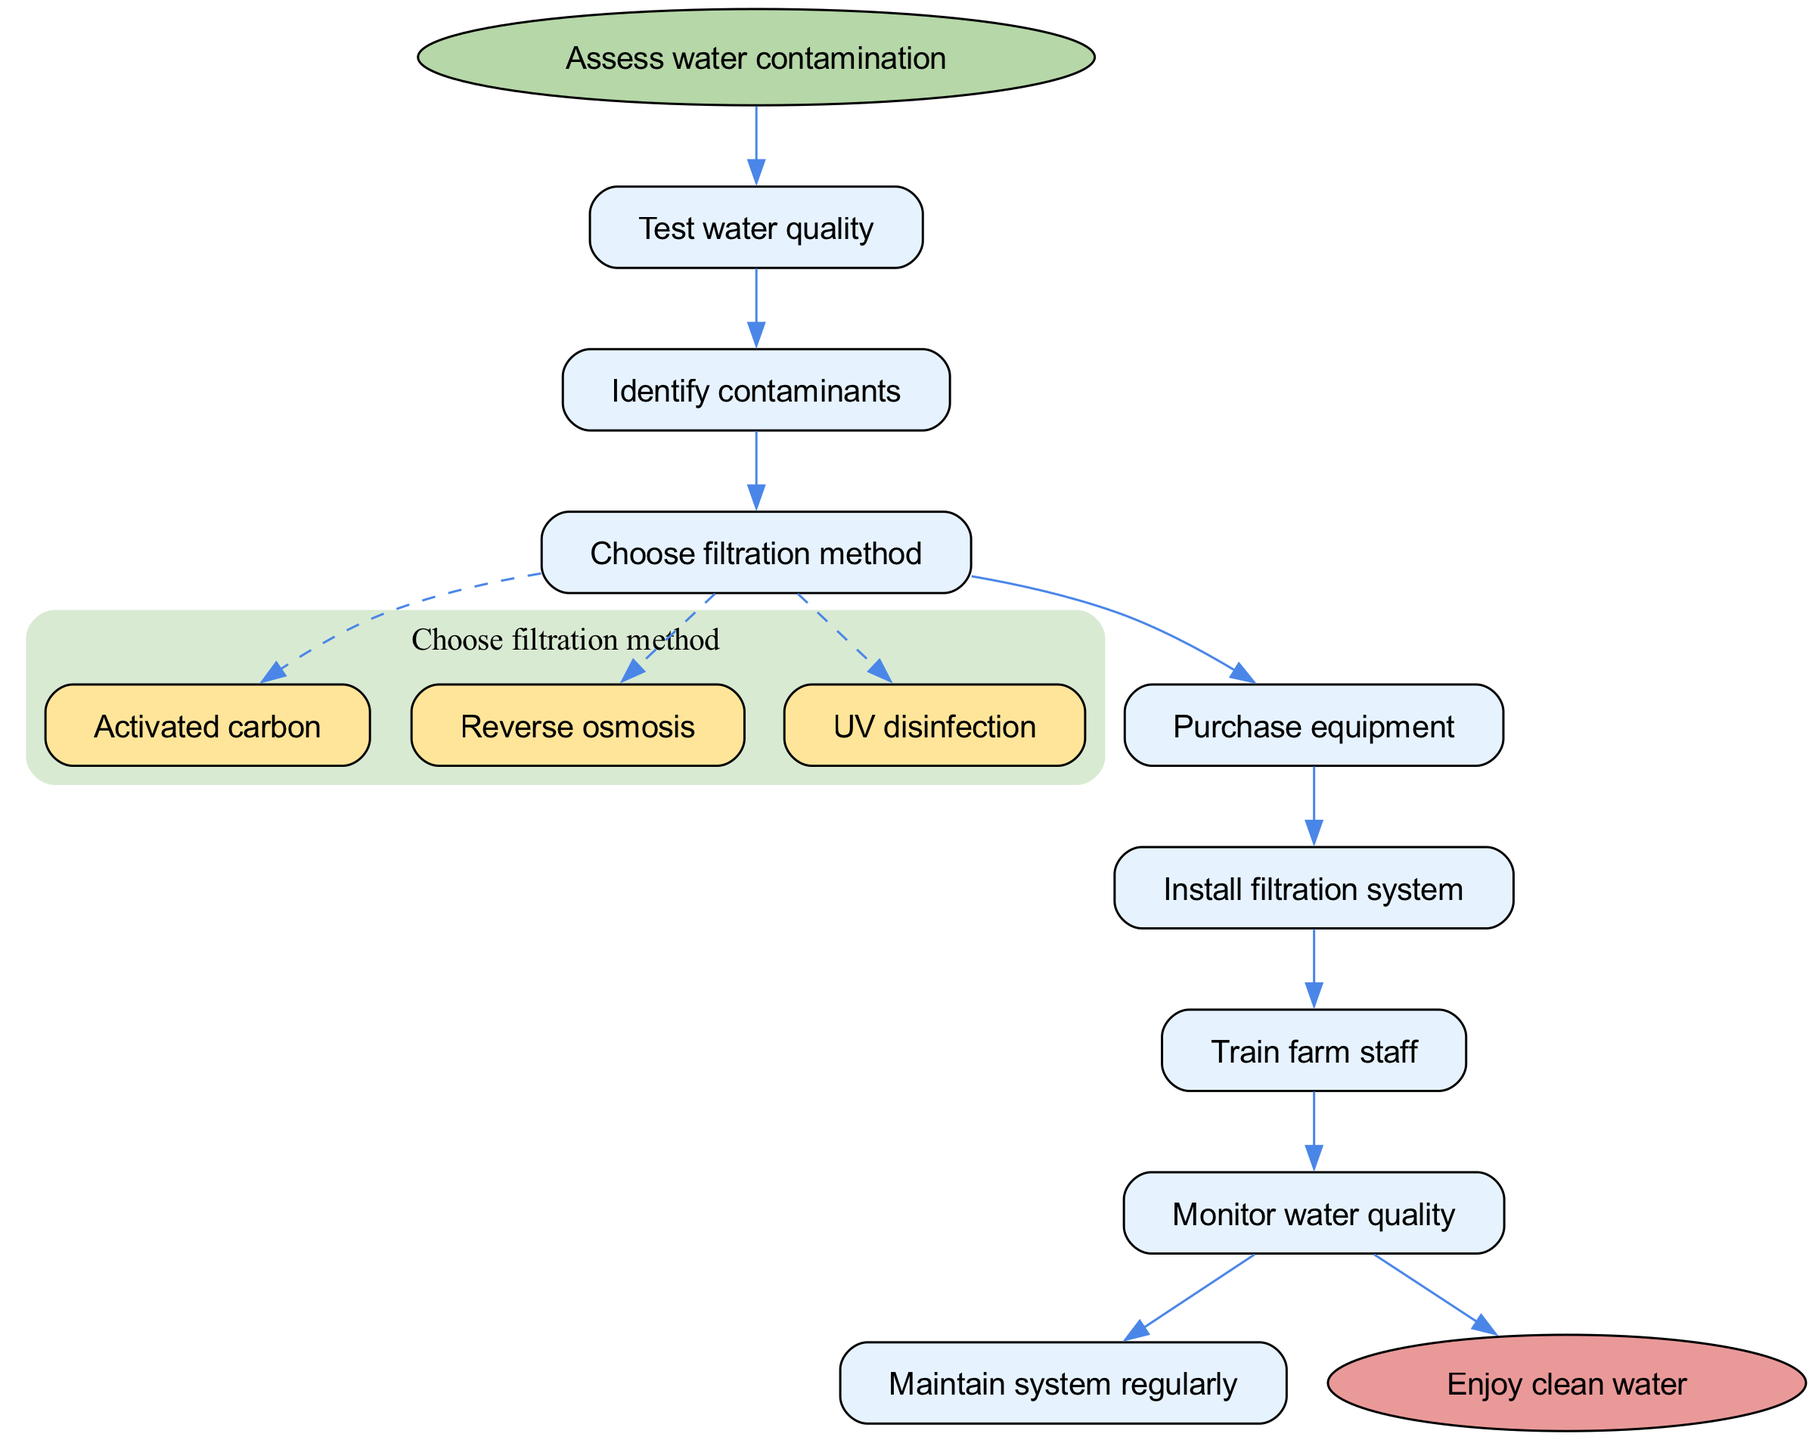What is the first step in the diagram? The first step in the diagram is labeled as "Assess water contamination." This is clearly indicated as the starting node connected directly to the subsequent step.
Answer: Assess water contamination How many steps are there in total? The diagram has a total of 7 steps listed sequentially, excluding the start and end nodes. Each step corresponds to an action required to implement the water filtration system.
Answer: 7 What follows after "Train farm staff"? The next step after "Train farm staff" is "Monitor water quality." The flow of the diagram indicates the connection between these two steps with an edge linking them.
Answer: Monitor water quality What are the options for filtration methods? The filtration methods presented as options are "Activated carbon," "Reverse osmosis," and "UV disinfection." These options are highlighted within the corresponding step in the diagram.
Answer: Activated carbon, Reverse osmosis, UV disinfection Which step comes after "Choose filtration method"? Following "Choose filtration method," the next step in the sequence is "Purchase equipment." This can be seen from the directed edge connecting these two steps in the diagram.
Answer: Purchase equipment What is the end node of the diagram? The end node of the diagram is labeled "Enjoy clean water." This indicates the completion of the process after implementing all the prior steps successfully.
Answer: Enjoy clean water Which step has options listed? The step titled "Choose filtration method" contains options listed. It represents a decision point in the flow chart where multiple filtration techniques can be chosen.
Answer: Choose filtration method What connects "Install filtration system" to the next step? The step "Install filtration system" connects to "Train farm staff" through a directed edge, indicating that after installation, training is the next action in the process.
Answer: Train farm staff 